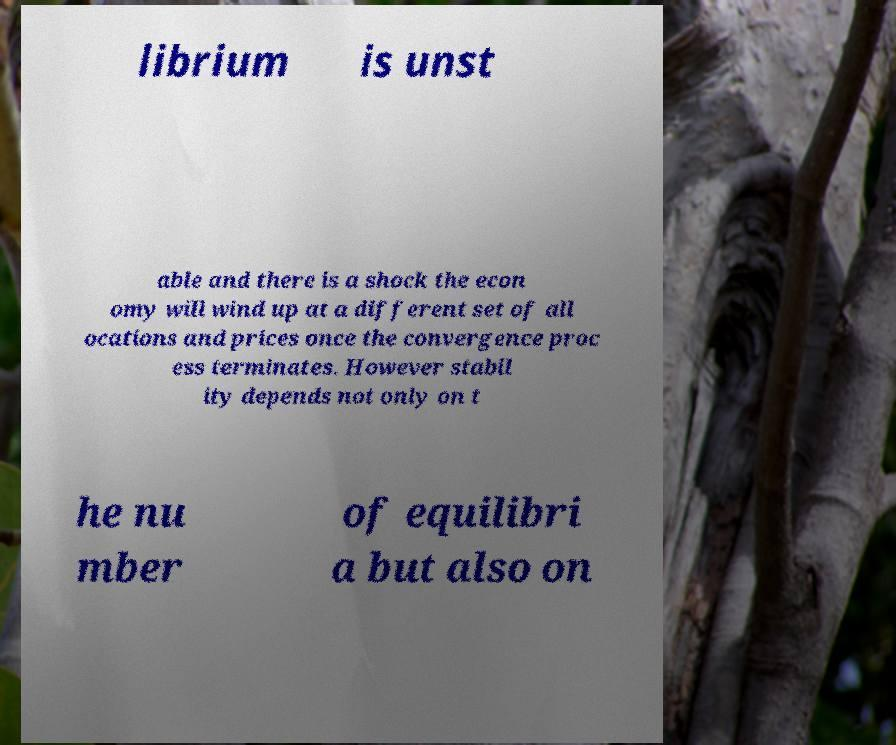Could you assist in decoding the text presented in this image and type it out clearly? librium is unst able and there is a shock the econ omy will wind up at a different set of all ocations and prices once the convergence proc ess terminates. However stabil ity depends not only on t he nu mber of equilibri a but also on 